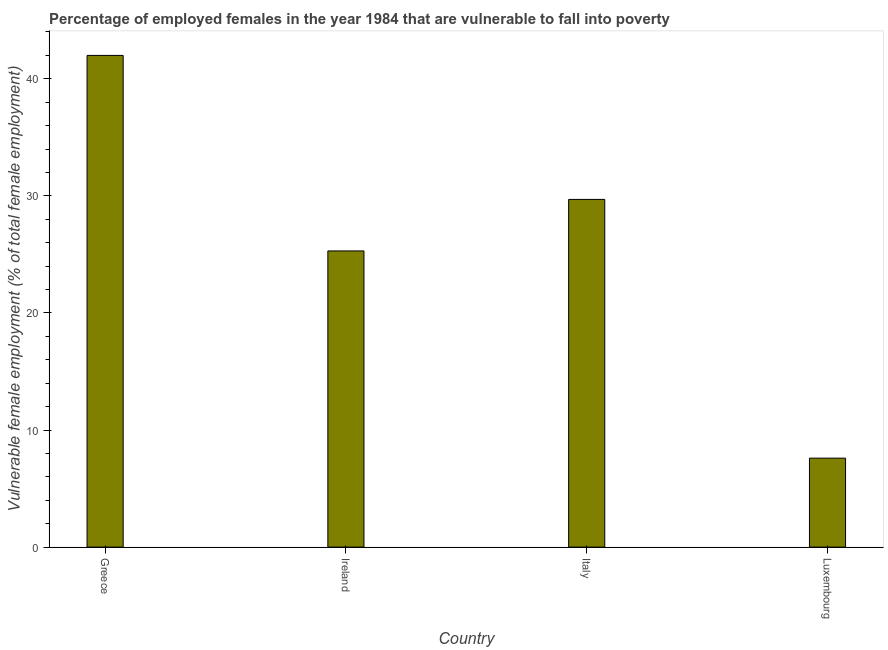Does the graph contain grids?
Your response must be concise. No. What is the title of the graph?
Make the answer very short. Percentage of employed females in the year 1984 that are vulnerable to fall into poverty. What is the label or title of the X-axis?
Keep it short and to the point. Country. What is the label or title of the Y-axis?
Your answer should be compact. Vulnerable female employment (% of total female employment). What is the percentage of employed females who are vulnerable to fall into poverty in Italy?
Make the answer very short. 29.7. Across all countries, what is the maximum percentage of employed females who are vulnerable to fall into poverty?
Offer a very short reply. 42. Across all countries, what is the minimum percentage of employed females who are vulnerable to fall into poverty?
Offer a terse response. 7.6. In which country was the percentage of employed females who are vulnerable to fall into poverty maximum?
Ensure brevity in your answer.  Greece. In which country was the percentage of employed females who are vulnerable to fall into poverty minimum?
Your answer should be compact. Luxembourg. What is the sum of the percentage of employed females who are vulnerable to fall into poverty?
Make the answer very short. 104.6. What is the difference between the percentage of employed females who are vulnerable to fall into poverty in Italy and Luxembourg?
Ensure brevity in your answer.  22.1. What is the average percentage of employed females who are vulnerable to fall into poverty per country?
Provide a succinct answer. 26.15. What is the median percentage of employed females who are vulnerable to fall into poverty?
Keep it short and to the point. 27.5. What is the ratio of the percentage of employed females who are vulnerable to fall into poverty in Greece to that in Luxembourg?
Make the answer very short. 5.53. What is the difference between the highest and the second highest percentage of employed females who are vulnerable to fall into poverty?
Your response must be concise. 12.3. What is the difference between the highest and the lowest percentage of employed females who are vulnerable to fall into poverty?
Ensure brevity in your answer.  34.4. How many bars are there?
Your answer should be very brief. 4. What is the difference between two consecutive major ticks on the Y-axis?
Provide a short and direct response. 10. What is the Vulnerable female employment (% of total female employment) of Ireland?
Offer a very short reply. 25.3. What is the Vulnerable female employment (% of total female employment) in Italy?
Make the answer very short. 29.7. What is the Vulnerable female employment (% of total female employment) in Luxembourg?
Offer a terse response. 7.6. What is the difference between the Vulnerable female employment (% of total female employment) in Greece and Italy?
Keep it short and to the point. 12.3. What is the difference between the Vulnerable female employment (% of total female employment) in Greece and Luxembourg?
Your response must be concise. 34.4. What is the difference between the Vulnerable female employment (% of total female employment) in Ireland and Luxembourg?
Give a very brief answer. 17.7. What is the difference between the Vulnerable female employment (% of total female employment) in Italy and Luxembourg?
Ensure brevity in your answer.  22.1. What is the ratio of the Vulnerable female employment (% of total female employment) in Greece to that in Ireland?
Your answer should be compact. 1.66. What is the ratio of the Vulnerable female employment (% of total female employment) in Greece to that in Italy?
Your answer should be very brief. 1.41. What is the ratio of the Vulnerable female employment (% of total female employment) in Greece to that in Luxembourg?
Provide a short and direct response. 5.53. What is the ratio of the Vulnerable female employment (% of total female employment) in Ireland to that in Italy?
Offer a terse response. 0.85. What is the ratio of the Vulnerable female employment (% of total female employment) in Ireland to that in Luxembourg?
Provide a short and direct response. 3.33. What is the ratio of the Vulnerable female employment (% of total female employment) in Italy to that in Luxembourg?
Your answer should be very brief. 3.91. 